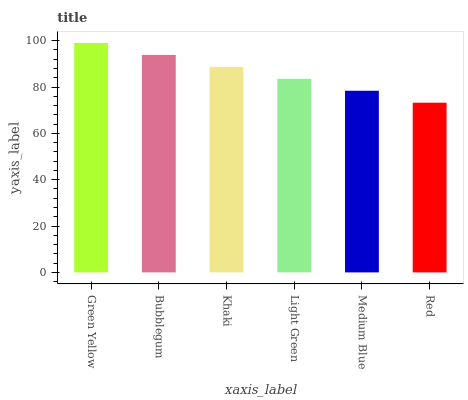Is Red the minimum?
Answer yes or no. Yes. Is Green Yellow the maximum?
Answer yes or no. Yes. Is Bubblegum the minimum?
Answer yes or no. No. Is Bubblegum the maximum?
Answer yes or no. No. Is Green Yellow greater than Bubblegum?
Answer yes or no. Yes. Is Bubblegum less than Green Yellow?
Answer yes or no. Yes. Is Bubblegum greater than Green Yellow?
Answer yes or no. No. Is Green Yellow less than Bubblegum?
Answer yes or no. No. Is Khaki the high median?
Answer yes or no. Yes. Is Light Green the low median?
Answer yes or no. Yes. Is Bubblegum the high median?
Answer yes or no. No. Is Red the low median?
Answer yes or no. No. 